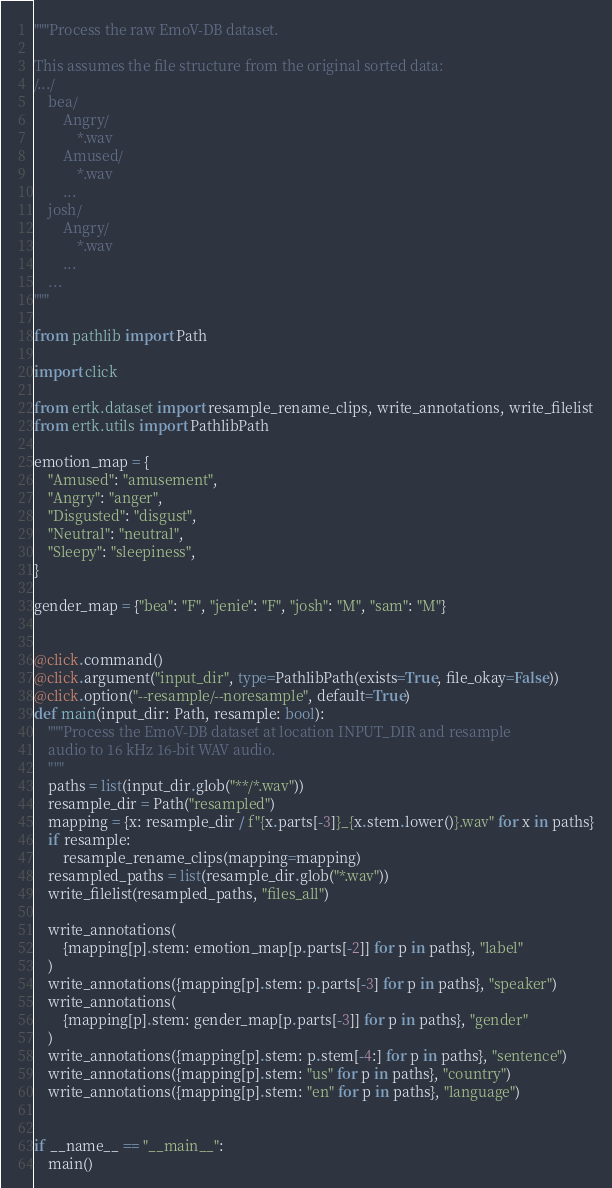Convert code to text. <code><loc_0><loc_0><loc_500><loc_500><_Python_>"""Process the raw EmoV-DB dataset.

This assumes the file structure from the original sorted data:
/.../
    bea/
        Angry/
            *.wav
        Amused/
            *.wav
        ...
    josh/
        Angry/
            *.wav
        ...
    ...
"""

from pathlib import Path

import click

from ertk.dataset import resample_rename_clips, write_annotations, write_filelist
from ertk.utils import PathlibPath

emotion_map = {
    "Amused": "amusement",
    "Angry": "anger",
    "Disgusted": "disgust",
    "Neutral": "neutral",
    "Sleepy": "sleepiness",
}

gender_map = {"bea": "F", "jenie": "F", "josh": "M", "sam": "M"}


@click.command()
@click.argument("input_dir", type=PathlibPath(exists=True, file_okay=False))
@click.option("--resample/--noresample", default=True)
def main(input_dir: Path, resample: bool):
    """Process the EmoV-DB dataset at location INPUT_DIR and resample
    audio to 16 kHz 16-bit WAV audio.
    """
    paths = list(input_dir.glob("**/*.wav"))
    resample_dir = Path("resampled")
    mapping = {x: resample_dir / f"{x.parts[-3]}_{x.stem.lower()}.wav" for x in paths}
    if resample:
        resample_rename_clips(mapping=mapping)
    resampled_paths = list(resample_dir.glob("*.wav"))
    write_filelist(resampled_paths, "files_all")

    write_annotations(
        {mapping[p].stem: emotion_map[p.parts[-2]] for p in paths}, "label"
    )
    write_annotations({mapping[p].stem: p.parts[-3] for p in paths}, "speaker")
    write_annotations(
        {mapping[p].stem: gender_map[p.parts[-3]] for p in paths}, "gender"
    )
    write_annotations({mapping[p].stem: p.stem[-4:] for p in paths}, "sentence")
    write_annotations({mapping[p].stem: "us" for p in paths}, "country")
    write_annotations({mapping[p].stem: "en" for p in paths}, "language")


if __name__ == "__main__":
    main()
</code> 